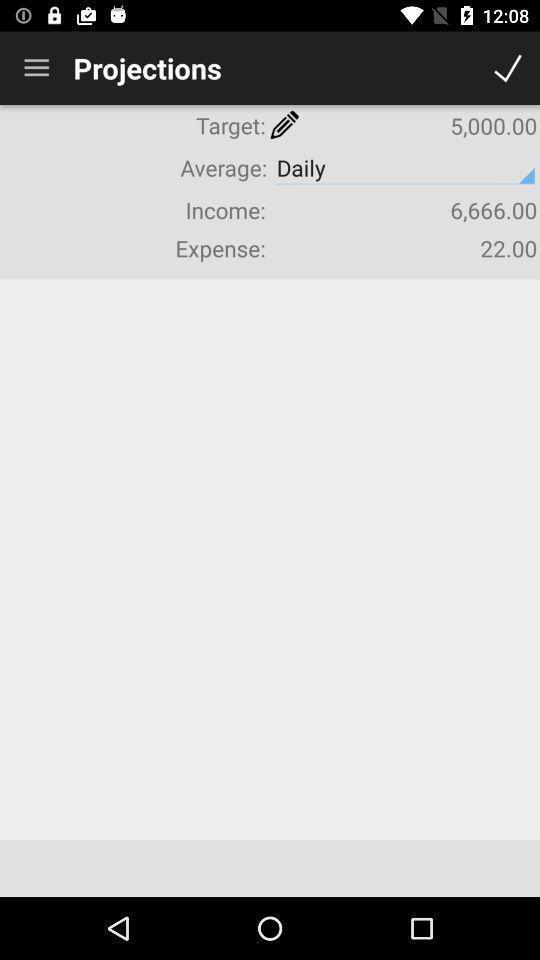Tell me what you see in this picture. Screen shows projections. 